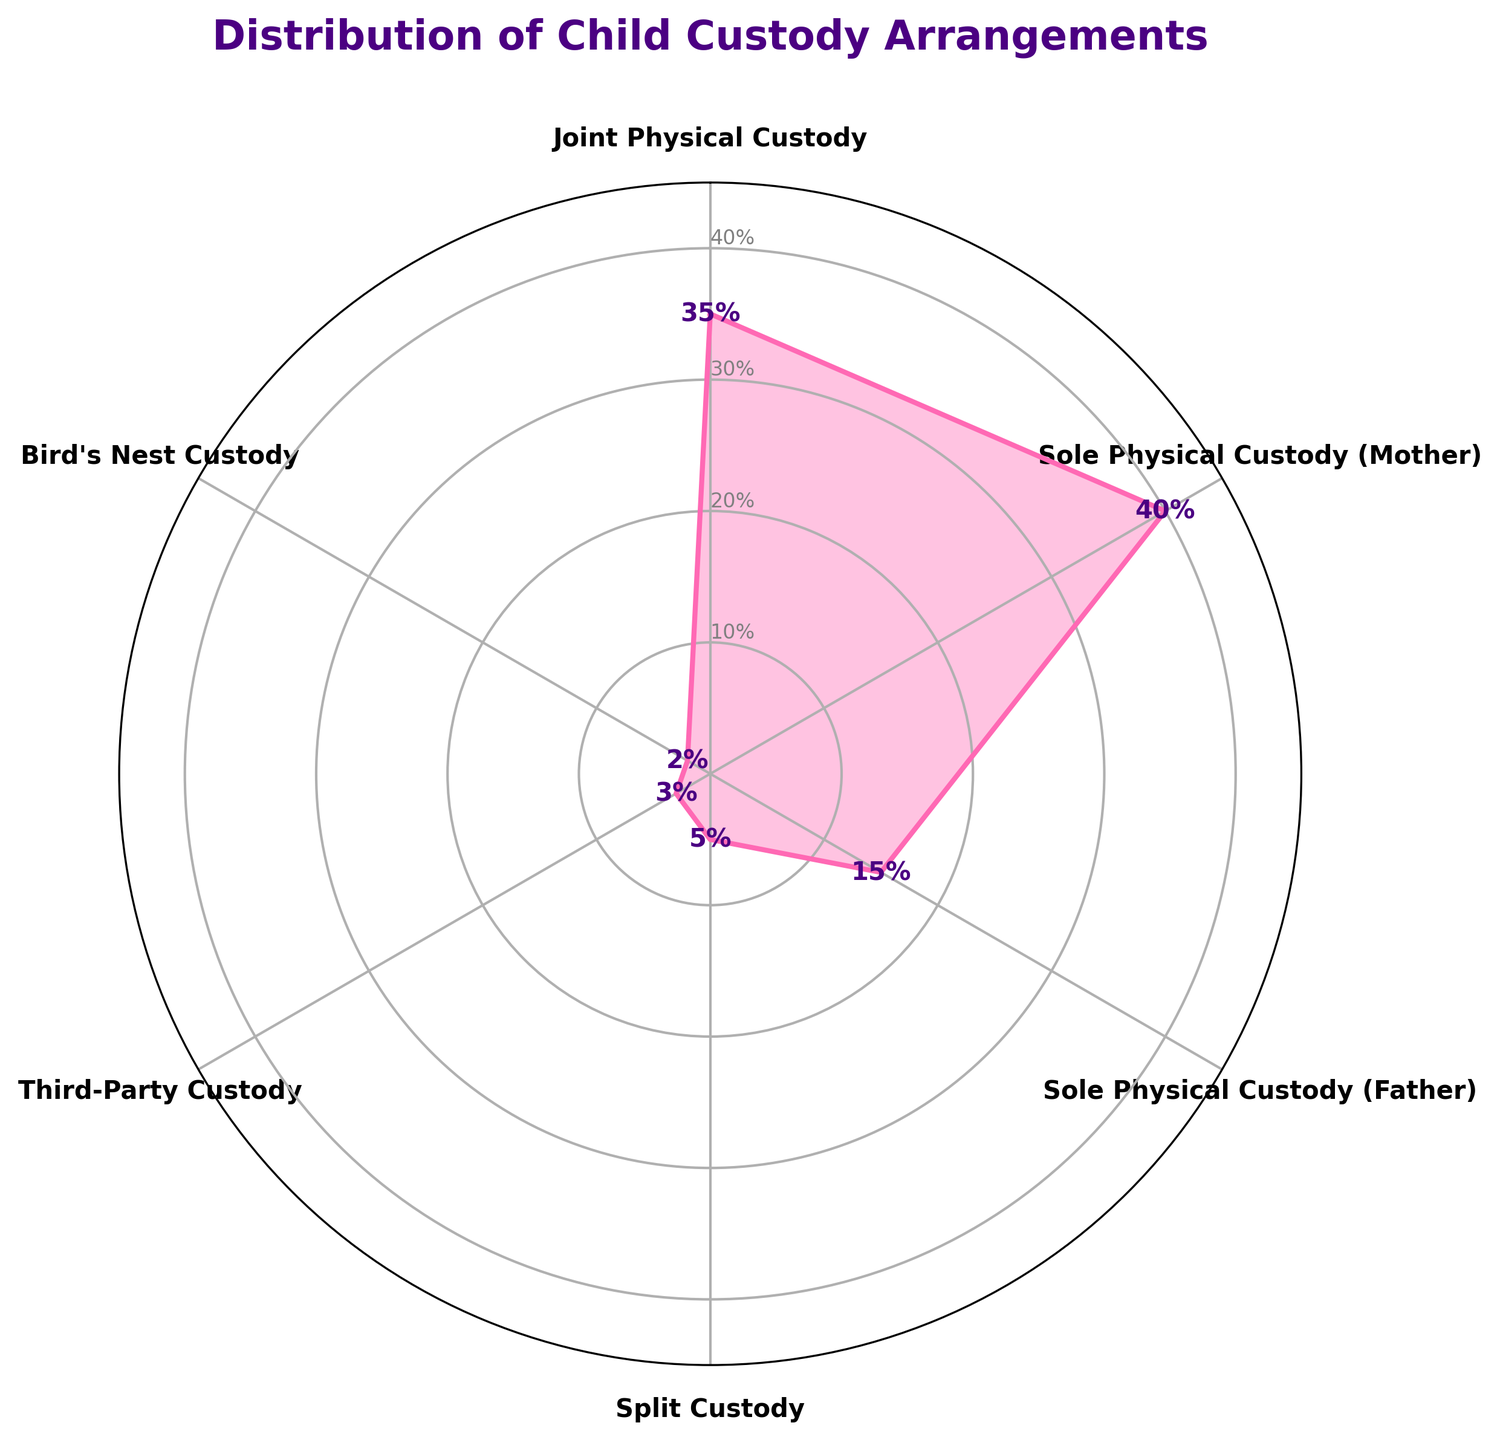What's the most common type of child custody arrangement? The figure shows various child custody arrangements, and the arrangement with the highest percentage is the most common. Joint Physical Custody has the highest value at 35%.
Answer: Joint Physical Custody Which child custody arrangement is the least common? Observing the figure, the custody arrangement with the smallest segment percentage is the least common. Bird's Nest Custody has the smallest value at 2%.
Answer: Bird's Nest Custody What is the total percentage of children in Sole Physical Custody arrangements? To find this, add the percentages of Sole Physical Custody (Mother) and Sole Physical Custody (Father). That is 40% + 15% = 55%.
Answer: 55% What's the percentage difference between Joint Physical Custody and Sole Physical Custody (Mother)? Subtract the percentage of Joint Physical Custody from Sole Physical Custody (Mother). That is 40% - 35% = 5%.
Answer: 5% How many data categories are there in the chart? The chart shows segments representing different custody arrangements. Counting these segments gives six categories.
Answer: Six Which custody arrangement constitutes 5% of the total? Looking at the percentages labeled in the segments, Split Custody is the one with a 5% value.
Answer: Split Custody What percentage of custody arrangements involve third parties? The chart shows a segment labeled Third-Party Custody, and the percentage given is 3%.
Answer: 3% Are there any custody arrangements with a 20% representation? After examining all segments in the chart, none of them represent exactly 20%. The closest is Sole Physical Custody (Mother) with 40%.
Answer: No What's the average percentage of custody arrangements excluding the most and least common types? Exclude Joint Physical Custody (35%) and Bird's Nest Custody (2%). Find the average of Sole Physical Custody (Mother) - 40%, Sole Physical Custody (Father) - 15%, Split Custody - 5%, and Third-Party Custody - 3%. The total is 63% among 4 categories. The average is 63 / 4 = 15.75%.
Answer: 15.75% Which custody type is exactly twice as common as Third-Party Custody? Third-Party Custody is 3%, and checking the chart, Split Custody is 5% which is almost twice, but not exact. However, by direct multiplication, there is no exact match, but Split Custody (5%) is near the required double percentage (6%).
Answer: None 